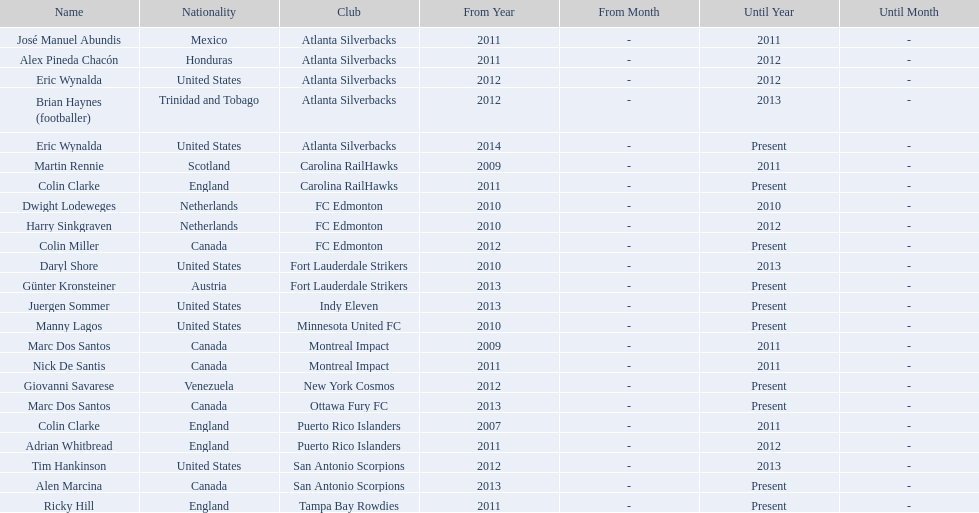What year did marc dos santos start as coach? 2009. Besides marc dos santos, what other coach started in 2009? Martin Rennie. 